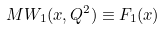<formula> <loc_0><loc_0><loc_500><loc_500>M W _ { 1 } ( x , Q ^ { 2 } ) \equiv F _ { 1 } ( x )</formula> 